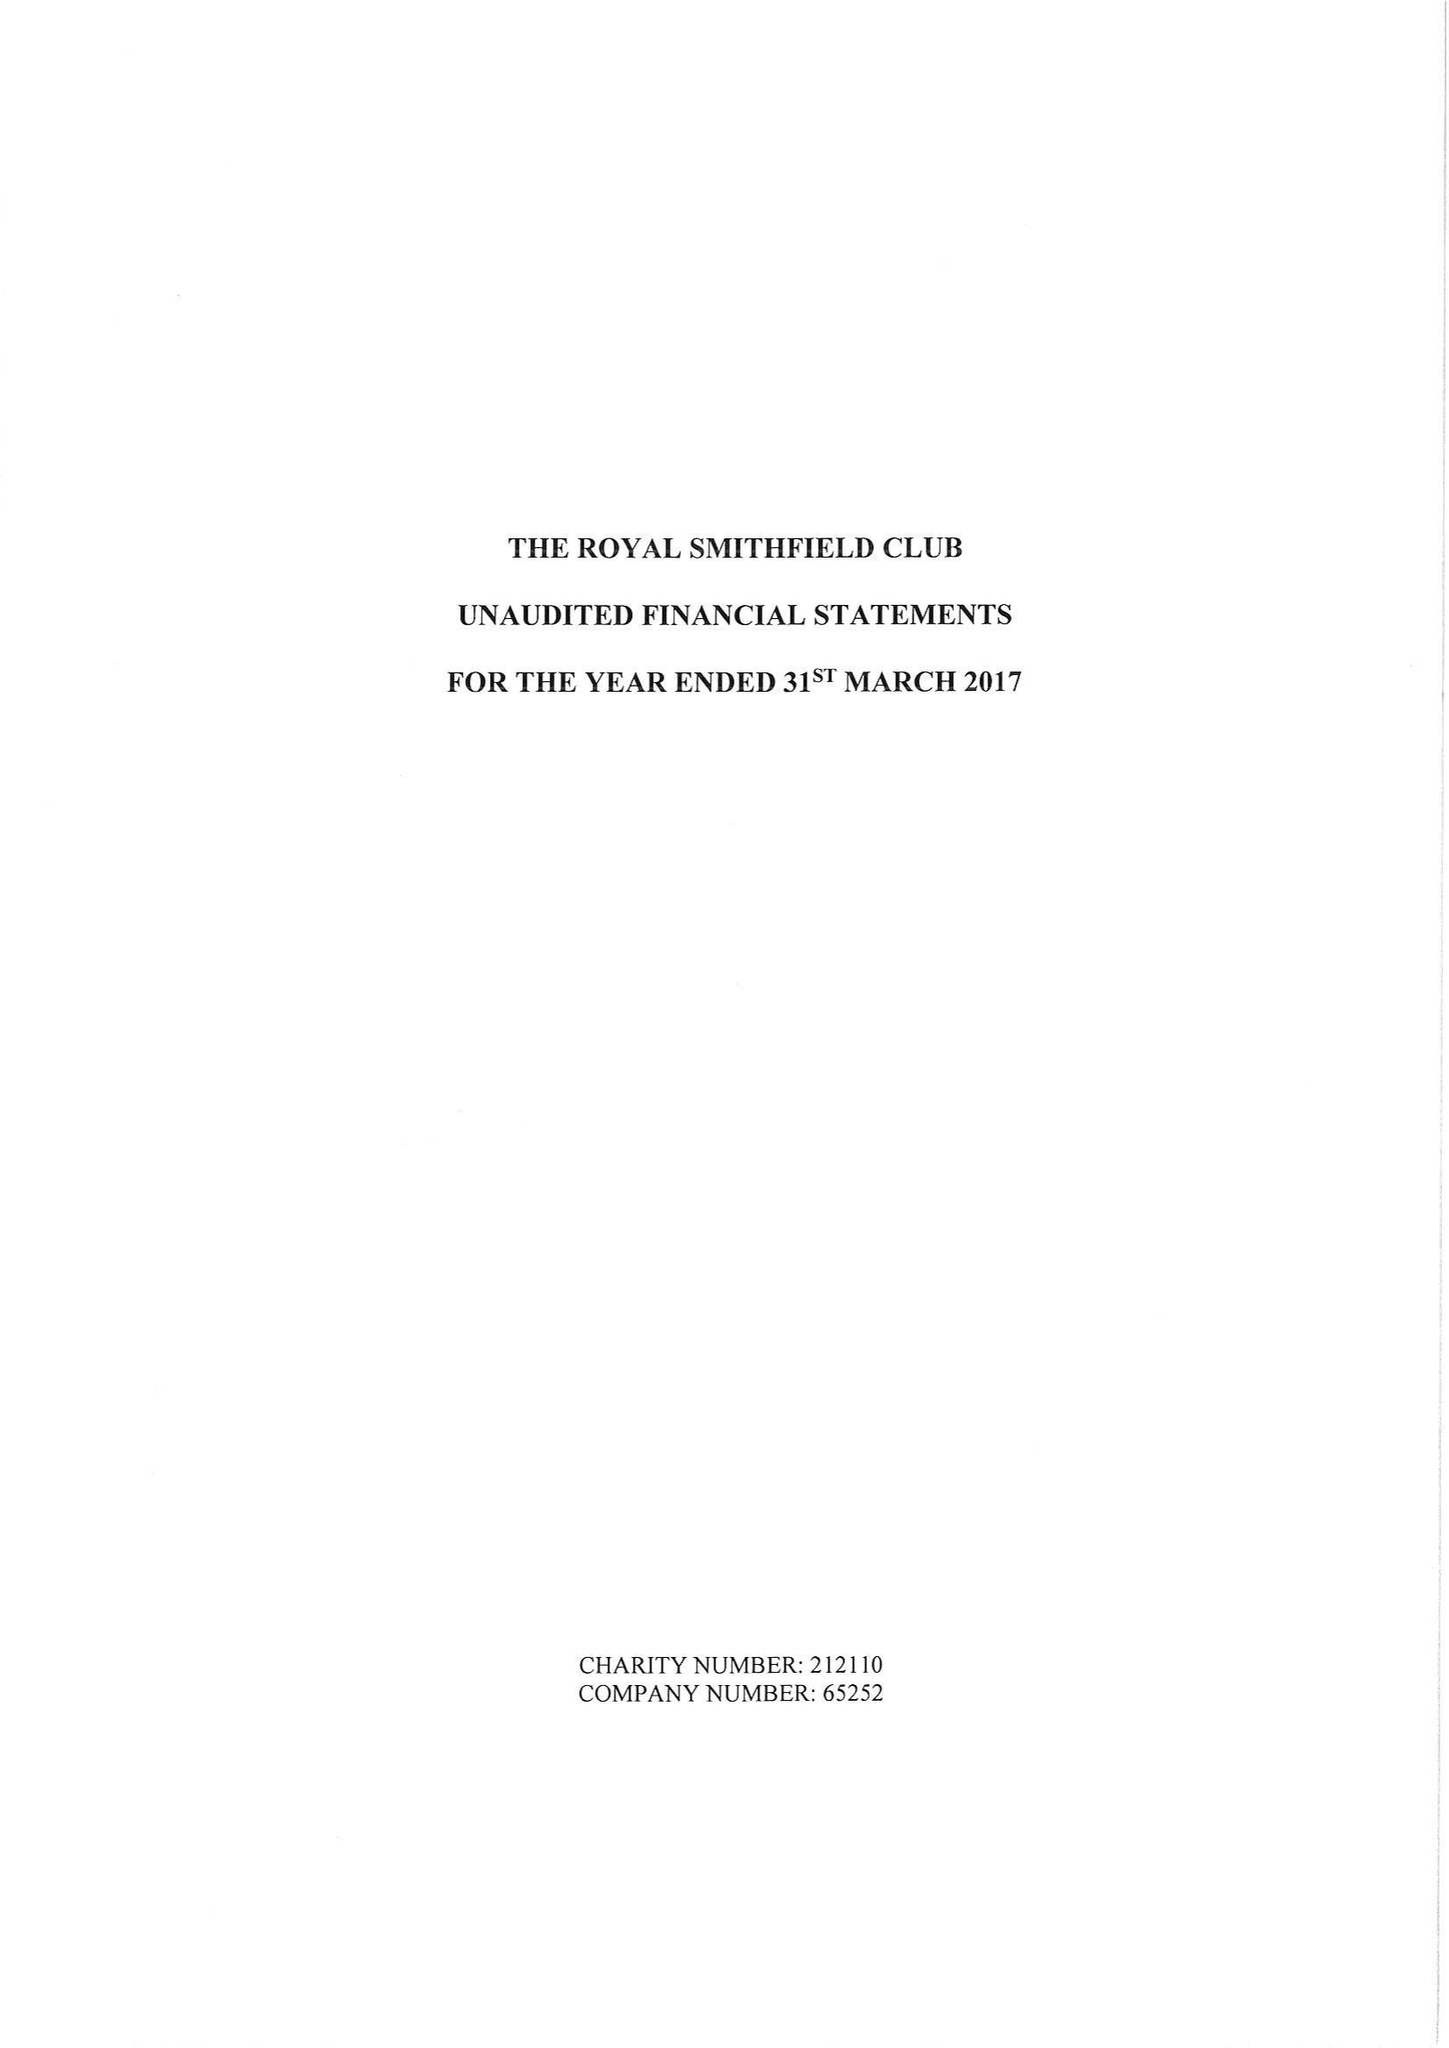What is the value for the charity_number?
Answer the question using a single word or phrase. 212110 